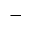<formula> <loc_0><loc_0><loc_500><loc_500>^ { - }</formula> 